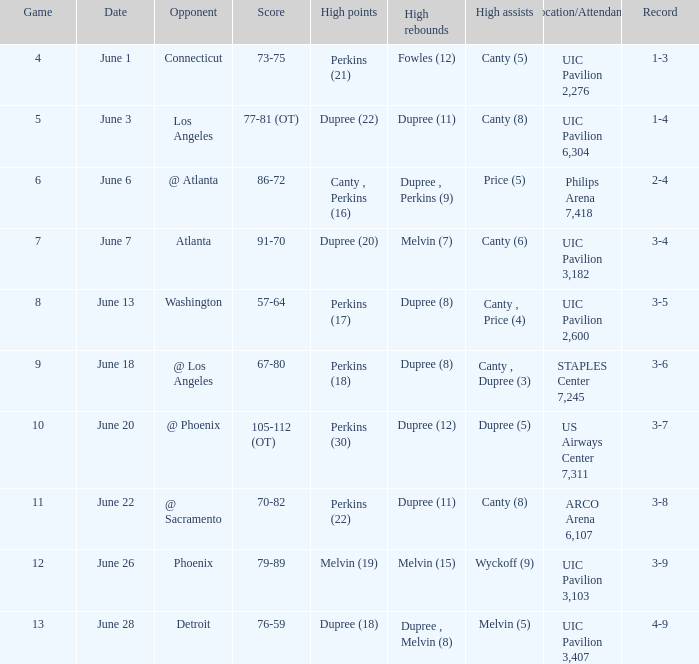What is the date of game 9? June 18. 